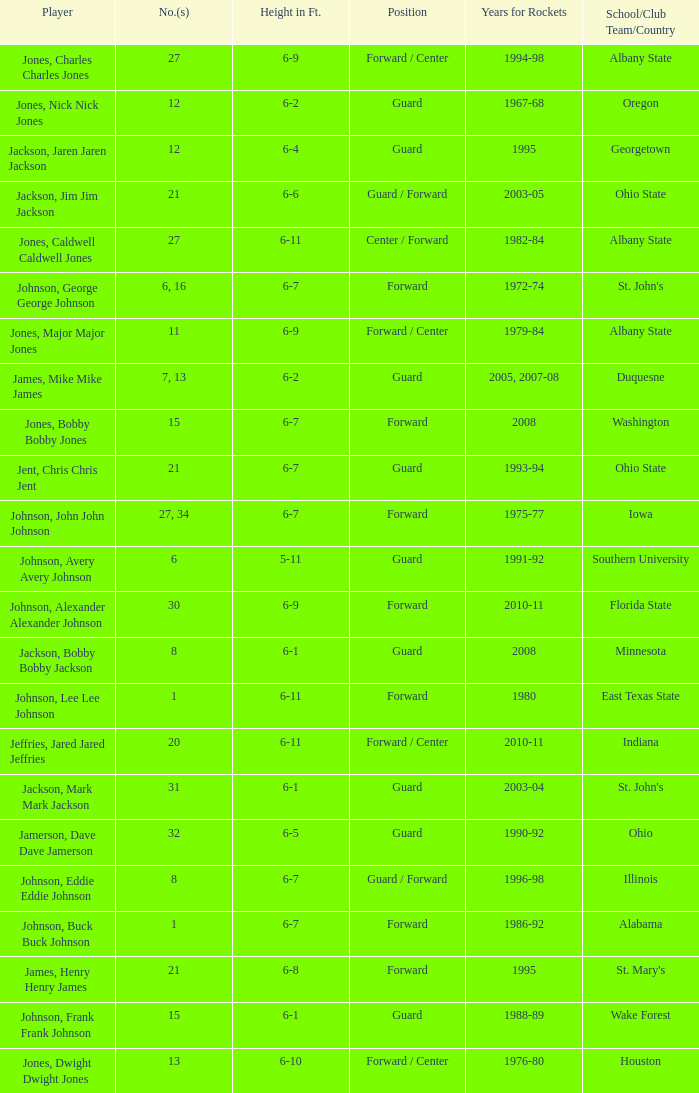How tall is the player jones, major major jones? 6-9. 